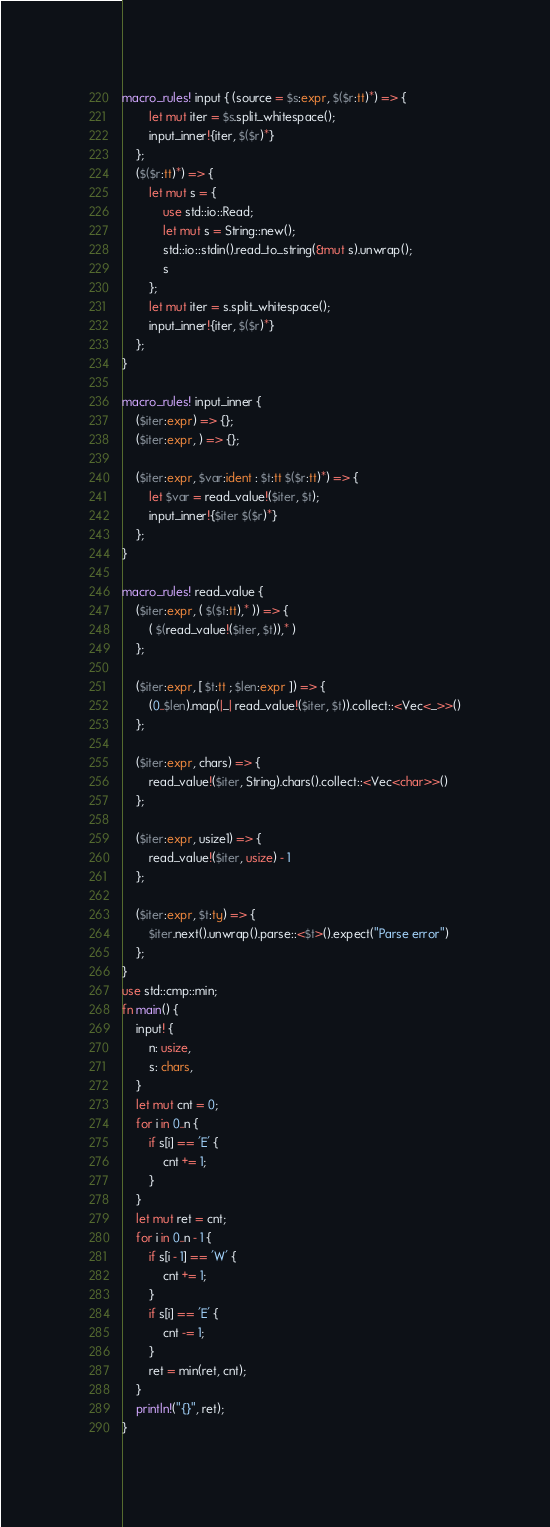Convert code to text. <code><loc_0><loc_0><loc_500><loc_500><_Rust_>macro_rules! input { (source = $s:expr, $($r:tt)*) => {
        let mut iter = $s.split_whitespace();
        input_inner!{iter, $($r)*}
    };
    ($($r:tt)*) => {
        let mut s = {
            use std::io::Read;
            let mut s = String::new();
            std::io::stdin().read_to_string(&mut s).unwrap();
            s
        };
        let mut iter = s.split_whitespace();
        input_inner!{iter, $($r)*}
    };
}

macro_rules! input_inner {
    ($iter:expr) => {};
    ($iter:expr, ) => {};

    ($iter:expr, $var:ident : $t:tt $($r:tt)*) => {
        let $var = read_value!($iter, $t);
        input_inner!{$iter $($r)*}
    };
}

macro_rules! read_value {
    ($iter:expr, ( $($t:tt),* )) => {
        ( $(read_value!($iter, $t)),* )
    };

    ($iter:expr, [ $t:tt ; $len:expr ]) => {
        (0..$len).map(|_| read_value!($iter, $t)).collect::<Vec<_>>()
    };

    ($iter:expr, chars) => {
        read_value!($iter, String).chars().collect::<Vec<char>>()
    };

    ($iter:expr, usize1) => {
        read_value!($iter, usize) - 1
    };

    ($iter:expr, $t:ty) => {
        $iter.next().unwrap().parse::<$t>().expect("Parse error")
    };
}
use std::cmp::min;
fn main() {
    input! {
        n: usize,
        s: chars,
    }
    let mut cnt = 0;
    for i in 0..n {
        if s[i] == 'E' {
            cnt += 1;
        }
    }
    let mut ret = cnt;
    for i in 0..n - 1 {
        if s[i - 1] == 'W' {
            cnt += 1;
        }
        if s[i] == 'E' {
            cnt -= 1;
        }
        ret = min(ret, cnt);
    }
    println!("{}", ret);
}
</code> 